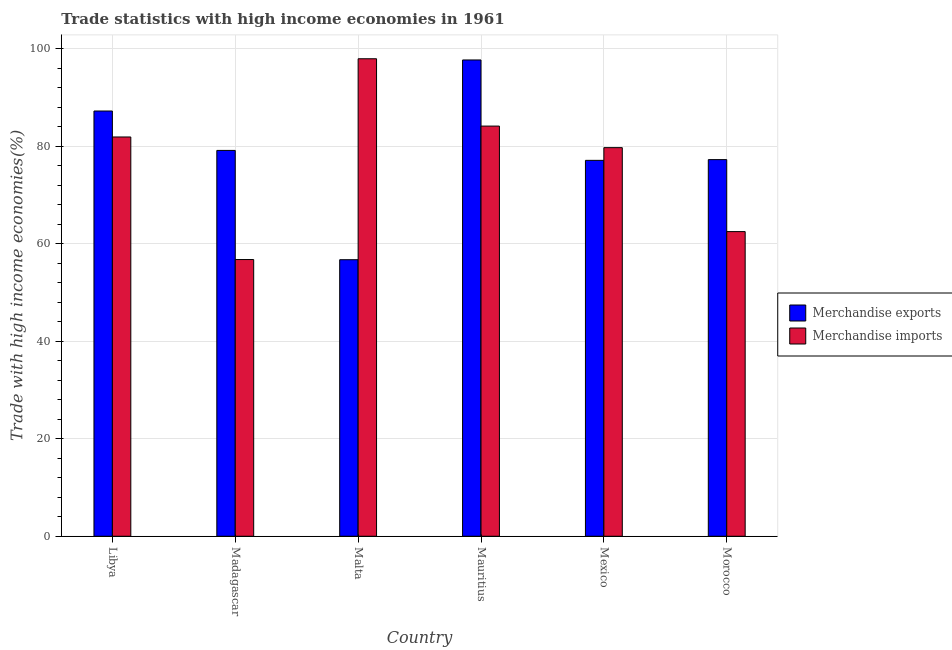How many different coloured bars are there?
Give a very brief answer. 2. Are the number of bars on each tick of the X-axis equal?
Ensure brevity in your answer.  Yes. What is the label of the 2nd group of bars from the left?
Provide a succinct answer. Madagascar. In how many cases, is the number of bars for a given country not equal to the number of legend labels?
Your answer should be compact. 0. What is the merchandise exports in Mexico?
Provide a succinct answer. 77.1. Across all countries, what is the maximum merchandise imports?
Your answer should be very brief. 97.93. Across all countries, what is the minimum merchandise imports?
Provide a short and direct response. 56.75. In which country was the merchandise exports maximum?
Provide a short and direct response. Mauritius. In which country was the merchandise exports minimum?
Offer a very short reply. Malta. What is the total merchandise imports in the graph?
Ensure brevity in your answer.  462.87. What is the difference between the merchandise imports in Mexico and that in Morocco?
Provide a short and direct response. 17.22. What is the difference between the merchandise exports in Madagascar and the merchandise imports in Malta?
Offer a terse response. -18.8. What is the average merchandise imports per country?
Keep it short and to the point. 77.15. What is the difference between the merchandise exports and merchandise imports in Morocco?
Make the answer very short. 14.76. What is the ratio of the merchandise imports in Mauritius to that in Morocco?
Your answer should be very brief. 1.35. What is the difference between the highest and the second highest merchandise exports?
Offer a very short reply. 10.47. What is the difference between the highest and the lowest merchandise exports?
Provide a short and direct response. 40.97. In how many countries, is the merchandise imports greater than the average merchandise imports taken over all countries?
Ensure brevity in your answer.  4. What does the 1st bar from the right in Morocco represents?
Make the answer very short. Merchandise imports. How many bars are there?
Your response must be concise. 12. How many countries are there in the graph?
Give a very brief answer. 6. What is the difference between two consecutive major ticks on the Y-axis?
Your answer should be very brief. 20. Where does the legend appear in the graph?
Give a very brief answer. Center right. How many legend labels are there?
Provide a succinct answer. 2. What is the title of the graph?
Your response must be concise. Trade statistics with high income economies in 1961. Does "By country of origin" appear as one of the legend labels in the graph?
Your answer should be very brief. No. What is the label or title of the Y-axis?
Offer a terse response. Trade with high income economies(%). What is the Trade with high income economies(%) of Merchandise exports in Libya?
Give a very brief answer. 87.21. What is the Trade with high income economies(%) in Merchandise imports in Libya?
Offer a terse response. 81.89. What is the Trade with high income economies(%) of Merchandise exports in Madagascar?
Provide a succinct answer. 79.13. What is the Trade with high income economies(%) of Merchandise imports in Madagascar?
Your answer should be compact. 56.75. What is the Trade with high income economies(%) in Merchandise exports in Malta?
Ensure brevity in your answer.  56.72. What is the Trade with high income economies(%) in Merchandise imports in Malta?
Offer a terse response. 97.93. What is the Trade with high income economies(%) of Merchandise exports in Mauritius?
Your answer should be compact. 97.68. What is the Trade with high income economies(%) in Merchandise imports in Mauritius?
Your response must be concise. 84.12. What is the Trade with high income economies(%) in Merchandise exports in Mexico?
Provide a short and direct response. 77.1. What is the Trade with high income economies(%) in Merchandise imports in Mexico?
Keep it short and to the point. 79.7. What is the Trade with high income economies(%) in Merchandise exports in Morocco?
Offer a very short reply. 77.24. What is the Trade with high income economies(%) in Merchandise imports in Morocco?
Ensure brevity in your answer.  62.48. Across all countries, what is the maximum Trade with high income economies(%) in Merchandise exports?
Provide a short and direct response. 97.68. Across all countries, what is the maximum Trade with high income economies(%) of Merchandise imports?
Your answer should be compact. 97.93. Across all countries, what is the minimum Trade with high income economies(%) in Merchandise exports?
Your response must be concise. 56.72. Across all countries, what is the minimum Trade with high income economies(%) in Merchandise imports?
Your answer should be very brief. 56.75. What is the total Trade with high income economies(%) in Merchandise exports in the graph?
Provide a short and direct response. 475.09. What is the total Trade with high income economies(%) in Merchandise imports in the graph?
Your answer should be very brief. 462.87. What is the difference between the Trade with high income economies(%) in Merchandise exports in Libya and that in Madagascar?
Provide a succinct answer. 8.08. What is the difference between the Trade with high income economies(%) in Merchandise imports in Libya and that in Madagascar?
Your answer should be very brief. 25.13. What is the difference between the Trade with high income economies(%) of Merchandise exports in Libya and that in Malta?
Offer a terse response. 30.5. What is the difference between the Trade with high income economies(%) in Merchandise imports in Libya and that in Malta?
Make the answer very short. -16.05. What is the difference between the Trade with high income economies(%) in Merchandise exports in Libya and that in Mauritius?
Give a very brief answer. -10.47. What is the difference between the Trade with high income economies(%) of Merchandise imports in Libya and that in Mauritius?
Offer a terse response. -2.24. What is the difference between the Trade with high income economies(%) in Merchandise exports in Libya and that in Mexico?
Offer a very short reply. 10.12. What is the difference between the Trade with high income economies(%) in Merchandise imports in Libya and that in Mexico?
Give a very brief answer. 2.19. What is the difference between the Trade with high income economies(%) of Merchandise exports in Libya and that in Morocco?
Offer a terse response. 9.97. What is the difference between the Trade with high income economies(%) of Merchandise imports in Libya and that in Morocco?
Provide a succinct answer. 19.4. What is the difference between the Trade with high income economies(%) of Merchandise exports in Madagascar and that in Malta?
Offer a terse response. 22.42. What is the difference between the Trade with high income economies(%) in Merchandise imports in Madagascar and that in Malta?
Provide a short and direct response. -41.18. What is the difference between the Trade with high income economies(%) in Merchandise exports in Madagascar and that in Mauritius?
Provide a short and direct response. -18.55. What is the difference between the Trade with high income economies(%) of Merchandise imports in Madagascar and that in Mauritius?
Offer a very short reply. -27.37. What is the difference between the Trade with high income economies(%) of Merchandise exports in Madagascar and that in Mexico?
Provide a succinct answer. 2.04. What is the difference between the Trade with high income economies(%) of Merchandise imports in Madagascar and that in Mexico?
Keep it short and to the point. -22.95. What is the difference between the Trade with high income economies(%) of Merchandise exports in Madagascar and that in Morocco?
Your response must be concise. 1.89. What is the difference between the Trade with high income economies(%) of Merchandise imports in Madagascar and that in Morocco?
Offer a terse response. -5.73. What is the difference between the Trade with high income economies(%) in Merchandise exports in Malta and that in Mauritius?
Provide a short and direct response. -40.97. What is the difference between the Trade with high income economies(%) in Merchandise imports in Malta and that in Mauritius?
Keep it short and to the point. 13.81. What is the difference between the Trade with high income economies(%) of Merchandise exports in Malta and that in Mexico?
Provide a succinct answer. -20.38. What is the difference between the Trade with high income economies(%) in Merchandise imports in Malta and that in Mexico?
Your response must be concise. 18.23. What is the difference between the Trade with high income economies(%) in Merchandise exports in Malta and that in Morocco?
Provide a succinct answer. -20.53. What is the difference between the Trade with high income economies(%) of Merchandise imports in Malta and that in Morocco?
Make the answer very short. 35.45. What is the difference between the Trade with high income economies(%) of Merchandise exports in Mauritius and that in Mexico?
Provide a short and direct response. 20.59. What is the difference between the Trade with high income economies(%) of Merchandise imports in Mauritius and that in Mexico?
Provide a succinct answer. 4.42. What is the difference between the Trade with high income economies(%) of Merchandise exports in Mauritius and that in Morocco?
Offer a terse response. 20.44. What is the difference between the Trade with high income economies(%) of Merchandise imports in Mauritius and that in Morocco?
Offer a very short reply. 21.64. What is the difference between the Trade with high income economies(%) in Merchandise exports in Mexico and that in Morocco?
Provide a short and direct response. -0.15. What is the difference between the Trade with high income economies(%) of Merchandise imports in Mexico and that in Morocco?
Make the answer very short. 17.22. What is the difference between the Trade with high income economies(%) in Merchandise exports in Libya and the Trade with high income economies(%) in Merchandise imports in Madagascar?
Provide a short and direct response. 30.46. What is the difference between the Trade with high income economies(%) in Merchandise exports in Libya and the Trade with high income economies(%) in Merchandise imports in Malta?
Your answer should be compact. -10.72. What is the difference between the Trade with high income economies(%) in Merchandise exports in Libya and the Trade with high income economies(%) in Merchandise imports in Mauritius?
Provide a succinct answer. 3.09. What is the difference between the Trade with high income economies(%) in Merchandise exports in Libya and the Trade with high income economies(%) in Merchandise imports in Mexico?
Your answer should be very brief. 7.52. What is the difference between the Trade with high income economies(%) of Merchandise exports in Libya and the Trade with high income economies(%) of Merchandise imports in Morocco?
Offer a very short reply. 24.73. What is the difference between the Trade with high income economies(%) in Merchandise exports in Madagascar and the Trade with high income economies(%) in Merchandise imports in Malta?
Provide a short and direct response. -18.8. What is the difference between the Trade with high income economies(%) of Merchandise exports in Madagascar and the Trade with high income economies(%) of Merchandise imports in Mauritius?
Provide a succinct answer. -4.99. What is the difference between the Trade with high income economies(%) of Merchandise exports in Madagascar and the Trade with high income economies(%) of Merchandise imports in Mexico?
Provide a succinct answer. -0.57. What is the difference between the Trade with high income economies(%) in Merchandise exports in Madagascar and the Trade with high income economies(%) in Merchandise imports in Morocco?
Your answer should be compact. 16.65. What is the difference between the Trade with high income economies(%) in Merchandise exports in Malta and the Trade with high income economies(%) in Merchandise imports in Mauritius?
Provide a succinct answer. -27.41. What is the difference between the Trade with high income economies(%) of Merchandise exports in Malta and the Trade with high income economies(%) of Merchandise imports in Mexico?
Provide a succinct answer. -22.98. What is the difference between the Trade with high income economies(%) of Merchandise exports in Malta and the Trade with high income economies(%) of Merchandise imports in Morocco?
Offer a very short reply. -5.77. What is the difference between the Trade with high income economies(%) of Merchandise exports in Mauritius and the Trade with high income economies(%) of Merchandise imports in Mexico?
Your answer should be compact. 17.98. What is the difference between the Trade with high income economies(%) of Merchandise exports in Mauritius and the Trade with high income economies(%) of Merchandise imports in Morocco?
Keep it short and to the point. 35.2. What is the difference between the Trade with high income economies(%) in Merchandise exports in Mexico and the Trade with high income economies(%) in Merchandise imports in Morocco?
Your answer should be compact. 14.61. What is the average Trade with high income economies(%) in Merchandise exports per country?
Ensure brevity in your answer.  79.18. What is the average Trade with high income economies(%) in Merchandise imports per country?
Your response must be concise. 77.15. What is the difference between the Trade with high income economies(%) in Merchandise exports and Trade with high income economies(%) in Merchandise imports in Libya?
Your answer should be very brief. 5.33. What is the difference between the Trade with high income economies(%) in Merchandise exports and Trade with high income economies(%) in Merchandise imports in Madagascar?
Your answer should be compact. 22.38. What is the difference between the Trade with high income economies(%) of Merchandise exports and Trade with high income economies(%) of Merchandise imports in Malta?
Provide a succinct answer. -41.22. What is the difference between the Trade with high income economies(%) in Merchandise exports and Trade with high income economies(%) in Merchandise imports in Mauritius?
Keep it short and to the point. 13.56. What is the difference between the Trade with high income economies(%) of Merchandise exports and Trade with high income economies(%) of Merchandise imports in Mexico?
Offer a very short reply. -2.6. What is the difference between the Trade with high income economies(%) of Merchandise exports and Trade with high income economies(%) of Merchandise imports in Morocco?
Offer a terse response. 14.76. What is the ratio of the Trade with high income economies(%) in Merchandise exports in Libya to that in Madagascar?
Ensure brevity in your answer.  1.1. What is the ratio of the Trade with high income economies(%) in Merchandise imports in Libya to that in Madagascar?
Provide a succinct answer. 1.44. What is the ratio of the Trade with high income economies(%) of Merchandise exports in Libya to that in Malta?
Ensure brevity in your answer.  1.54. What is the ratio of the Trade with high income economies(%) of Merchandise imports in Libya to that in Malta?
Your answer should be very brief. 0.84. What is the ratio of the Trade with high income economies(%) in Merchandise exports in Libya to that in Mauritius?
Offer a terse response. 0.89. What is the ratio of the Trade with high income economies(%) of Merchandise imports in Libya to that in Mauritius?
Your response must be concise. 0.97. What is the ratio of the Trade with high income economies(%) of Merchandise exports in Libya to that in Mexico?
Give a very brief answer. 1.13. What is the ratio of the Trade with high income economies(%) of Merchandise imports in Libya to that in Mexico?
Provide a succinct answer. 1.03. What is the ratio of the Trade with high income economies(%) of Merchandise exports in Libya to that in Morocco?
Your response must be concise. 1.13. What is the ratio of the Trade with high income economies(%) of Merchandise imports in Libya to that in Morocco?
Keep it short and to the point. 1.31. What is the ratio of the Trade with high income economies(%) of Merchandise exports in Madagascar to that in Malta?
Make the answer very short. 1.4. What is the ratio of the Trade with high income economies(%) of Merchandise imports in Madagascar to that in Malta?
Your answer should be very brief. 0.58. What is the ratio of the Trade with high income economies(%) of Merchandise exports in Madagascar to that in Mauritius?
Ensure brevity in your answer.  0.81. What is the ratio of the Trade with high income economies(%) in Merchandise imports in Madagascar to that in Mauritius?
Make the answer very short. 0.67. What is the ratio of the Trade with high income economies(%) of Merchandise exports in Madagascar to that in Mexico?
Offer a terse response. 1.03. What is the ratio of the Trade with high income economies(%) in Merchandise imports in Madagascar to that in Mexico?
Give a very brief answer. 0.71. What is the ratio of the Trade with high income economies(%) in Merchandise exports in Madagascar to that in Morocco?
Ensure brevity in your answer.  1.02. What is the ratio of the Trade with high income economies(%) of Merchandise imports in Madagascar to that in Morocco?
Offer a terse response. 0.91. What is the ratio of the Trade with high income economies(%) of Merchandise exports in Malta to that in Mauritius?
Keep it short and to the point. 0.58. What is the ratio of the Trade with high income economies(%) of Merchandise imports in Malta to that in Mauritius?
Offer a terse response. 1.16. What is the ratio of the Trade with high income economies(%) of Merchandise exports in Malta to that in Mexico?
Provide a succinct answer. 0.74. What is the ratio of the Trade with high income economies(%) of Merchandise imports in Malta to that in Mexico?
Your answer should be very brief. 1.23. What is the ratio of the Trade with high income economies(%) of Merchandise exports in Malta to that in Morocco?
Provide a succinct answer. 0.73. What is the ratio of the Trade with high income economies(%) in Merchandise imports in Malta to that in Morocco?
Ensure brevity in your answer.  1.57. What is the ratio of the Trade with high income economies(%) in Merchandise exports in Mauritius to that in Mexico?
Provide a succinct answer. 1.27. What is the ratio of the Trade with high income economies(%) of Merchandise imports in Mauritius to that in Mexico?
Give a very brief answer. 1.06. What is the ratio of the Trade with high income economies(%) in Merchandise exports in Mauritius to that in Morocco?
Your answer should be very brief. 1.26. What is the ratio of the Trade with high income economies(%) of Merchandise imports in Mauritius to that in Morocco?
Provide a short and direct response. 1.35. What is the ratio of the Trade with high income economies(%) of Merchandise imports in Mexico to that in Morocco?
Offer a terse response. 1.28. What is the difference between the highest and the second highest Trade with high income economies(%) in Merchandise exports?
Keep it short and to the point. 10.47. What is the difference between the highest and the second highest Trade with high income economies(%) of Merchandise imports?
Make the answer very short. 13.81. What is the difference between the highest and the lowest Trade with high income economies(%) in Merchandise exports?
Offer a very short reply. 40.97. What is the difference between the highest and the lowest Trade with high income economies(%) of Merchandise imports?
Your response must be concise. 41.18. 